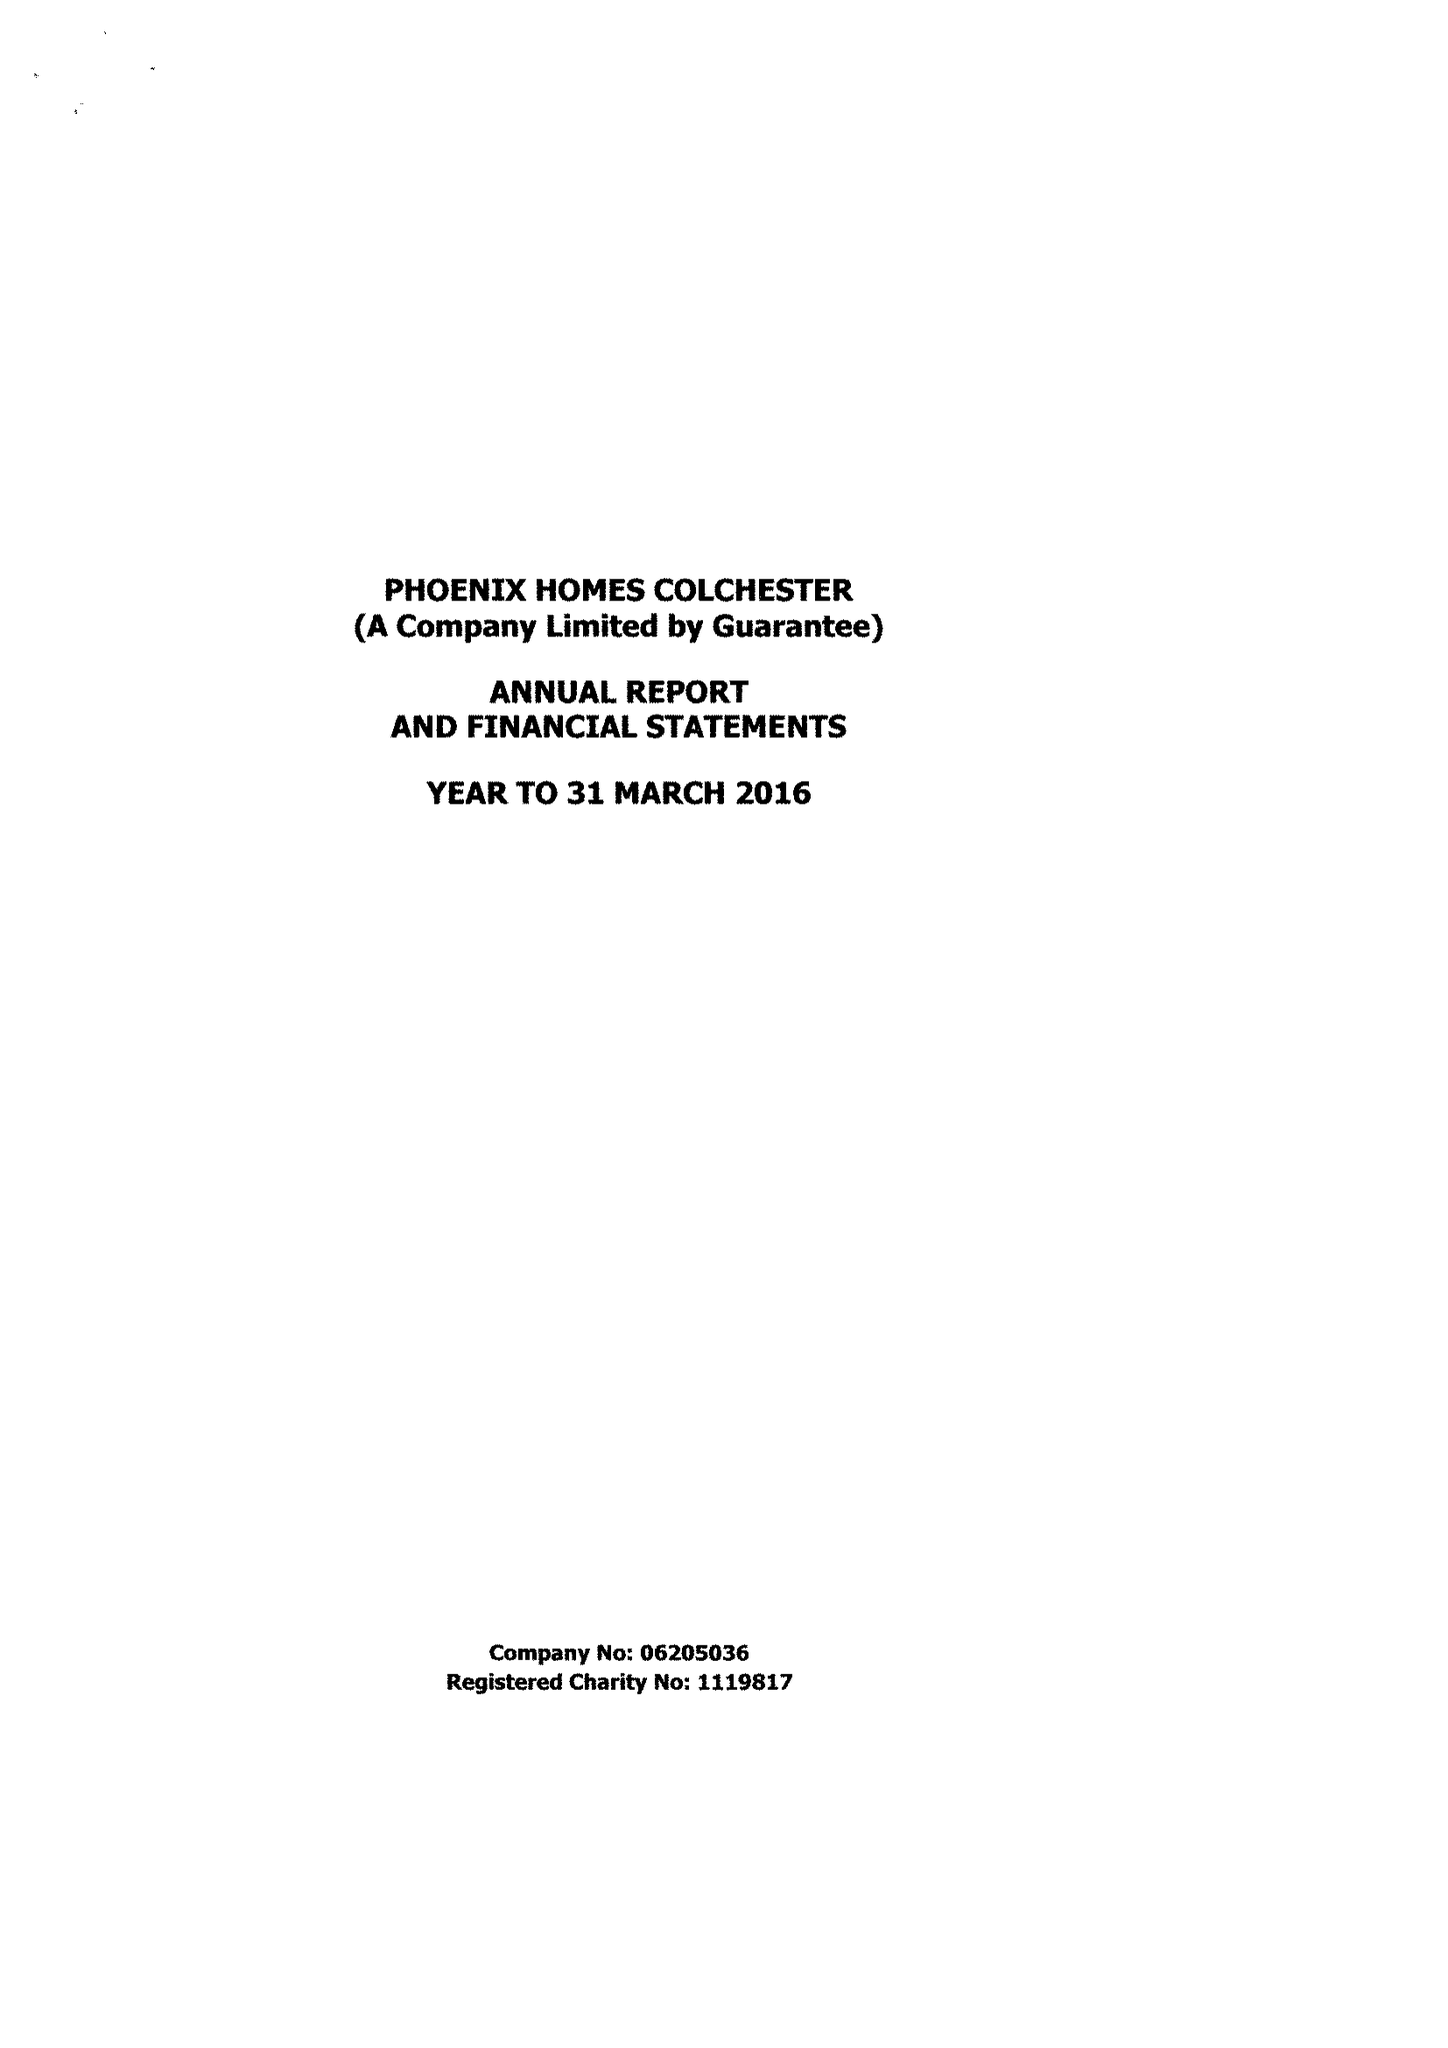What is the value for the address__postcode?
Answer the question using a single word or phrase. CO3 9DE 